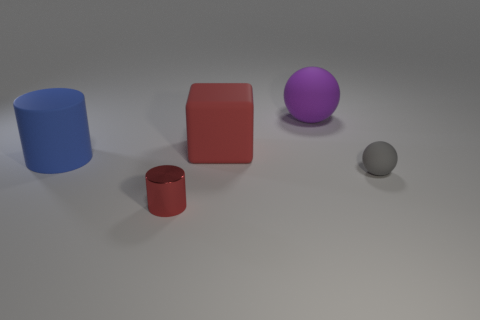Add 2 big purple matte balls. How many objects exist? 7 Subtract all cylinders. How many objects are left? 3 Add 4 big red things. How many big red things are left? 5 Add 2 small gray balls. How many small gray balls exist? 3 Subtract 0 yellow cubes. How many objects are left? 5 Subtract all large purple balls. Subtract all large brown rubber blocks. How many objects are left? 4 